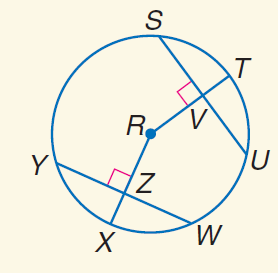Answer the mathemtical geometry problem and directly provide the correct option letter.
Question: In \odot R, S U = 20, Y W = 20, and m \widehat Y X = 45. Find m \widehat S U.
Choices: A: 20 B: 30 C: 45 D: 90 D 